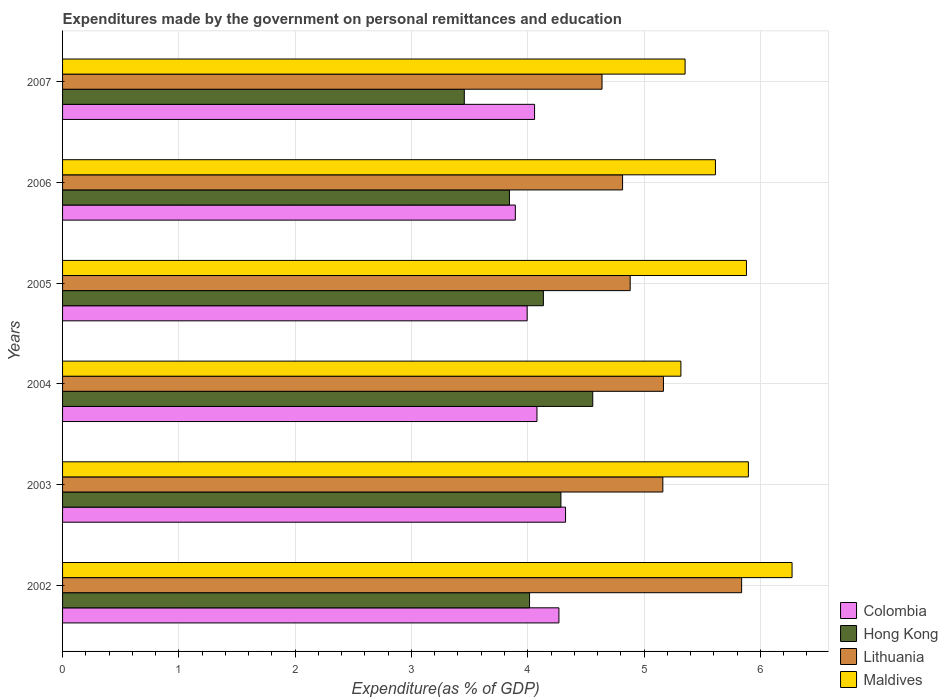How many groups of bars are there?
Provide a short and direct response. 6. Are the number of bars on each tick of the Y-axis equal?
Make the answer very short. Yes. How many bars are there on the 1st tick from the top?
Your response must be concise. 4. What is the expenditures made by the government on personal remittances and education in Lithuania in 2007?
Provide a short and direct response. 4.64. Across all years, what is the maximum expenditures made by the government on personal remittances and education in Hong Kong?
Give a very brief answer. 4.56. Across all years, what is the minimum expenditures made by the government on personal remittances and education in Maldives?
Provide a succinct answer. 5.32. What is the total expenditures made by the government on personal remittances and education in Hong Kong in the graph?
Your response must be concise. 24.29. What is the difference between the expenditures made by the government on personal remittances and education in Colombia in 2004 and that in 2005?
Your answer should be very brief. 0.08. What is the difference between the expenditures made by the government on personal remittances and education in Maldives in 2007 and the expenditures made by the government on personal remittances and education in Colombia in 2003?
Give a very brief answer. 1.03. What is the average expenditures made by the government on personal remittances and education in Maldives per year?
Offer a terse response. 5.72. In the year 2003, what is the difference between the expenditures made by the government on personal remittances and education in Maldives and expenditures made by the government on personal remittances and education in Colombia?
Ensure brevity in your answer.  1.57. In how many years, is the expenditures made by the government on personal remittances and education in Lithuania greater than 2.4 %?
Your answer should be compact. 6. What is the ratio of the expenditures made by the government on personal remittances and education in Hong Kong in 2002 to that in 2006?
Your answer should be very brief. 1.04. Is the expenditures made by the government on personal remittances and education in Hong Kong in 2005 less than that in 2007?
Provide a short and direct response. No. What is the difference between the highest and the second highest expenditures made by the government on personal remittances and education in Maldives?
Your response must be concise. 0.38. What is the difference between the highest and the lowest expenditures made by the government on personal remittances and education in Hong Kong?
Give a very brief answer. 1.1. In how many years, is the expenditures made by the government on personal remittances and education in Hong Kong greater than the average expenditures made by the government on personal remittances and education in Hong Kong taken over all years?
Make the answer very short. 3. Is it the case that in every year, the sum of the expenditures made by the government on personal remittances and education in Hong Kong and expenditures made by the government on personal remittances and education in Maldives is greater than the sum of expenditures made by the government on personal remittances and education in Colombia and expenditures made by the government on personal remittances and education in Lithuania?
Offer a terse response. Yes. What does the 1st bar from the top in 2007 represents?
Provide a short and direct response. Maldives. Is it the case that in every year, the sum of the expenditures made by the government on personal remittances and education in Maldives and expenditures made by the government on personal remittances and education in Hong Kong is greater than the expenditures made by the government on personal remittances and education in Lithuania?
Provide a short and direct response. Yes. Are all the bars in the graph horizontal?
Your answer should be compact. Yes. How many years are there in the graph?
Your answer should be very brief. 6. What is the difference between two consecutive major ticks on the X-axis?
Give a very brief answer. 1. Are the values on the major ticks of X-axis written in scientific E-notation?
Your answer should be compact. No. Where does the legend appear in the graph?
Ensure brevity in your answer.  Bottom right. How are the legend labels stacked?
Your response must be concise. Vertical. What is the title of the graph?
Your answer should be compact. Expenditures made by the government on personal remittances and education. What is the label or title of the X-axis?
Your answer should be very brief. Expenditure(as % of GDP). What is the label or title of the Y-axis?
Provide a short and direct response. Years. What is the Expenditure(as % of GDP) of Colombia in 2002?
Ensure brevity in your answer.  4.27. What is the Expenditure(as % of GDP) of Hong Kong in 2002?
Provide a succinct answer. 4.02. What is the Expenditure(as % of GDP) in Lithuania in 2002?
Your answer should be very brief. 5.84. What is the Expenditure(as % of GDP) of Maldives in 2002?
Ensure brevity in your answer.  6.27. What is the Expenditure(as % of GDP) in Colombia in 2003?
Your response must be concise. 4.33. What is the Expenditure(as % of GDP) in Hong Kong in 2003?
Offer a terse response. 4.29. What is the Expenditure(as % of GDP) in Lithuania in 2003?
Offer a very short reply. 5.16. What is the Expenditure(as % of GDP) of Maldives in 2003?
Ensure brevity in your answer.  5.9. What is the Expenditure(as % of GDP) in Colombia in 2004?
Your answer should be very brief. 4.08. What is the Expenditure(as % of GDP) of Hong Kong in 2004?
Your answer should be compact. 4.56. What is the Expenditure(as % of GDP) of Lithuania in 2004?
Offer a terse response. 5.17. What is the Expenditure(as % of GDP) of Maldives in 2004?
Provide a short and direct response. 5.32. What is the Expenditure(as % of GDP) in Colombia in 2005?
Offer a terse response. 4. What is the Expenditure(as % of GDP) of Hong Kong in 2005?
Provide a succinct answer. 4.13. What is the Expenditure(as % of GDP) in Lithuania in 2005?
Ensure brevity in your answer.  4.88. What is the Expenditure(as % of GDP) in Maldives in 2005?
Provide a succinct answer. 5.88. What is the Expenditure(as % of GDP) in Colombia in 2006?
Keep it short and to the point. 3.89. What is the Expenditure(as % of GDP) in Hong Kong in 2006?
Offer a very short reply. 3.84. What is the Expenditure(as % of GDP) of Lithuania in 2006?
Offer a terse response. 4.82. What is the Expenditure(as % of GDP) in Maldives in 2006?
Make the answer very short. 5.61. What is the Expenditure(as % of GDP) in Colombia in 2007?
Offer a terse response. 4.06. What is the Expenditure(as % of GDP) of Hong Kong in 2007?
Provide a succinct answer. 3.45. What is the Expenditure(as % of GDP) of Lithuania in 2007?
Ensure brevity in your answer.  4.64. What is the Expenditure(as % of GDP) in Maldives in 2007?
Provide a short and direct response. 5.35. Across all years, what is the maximum Expenditure(as % of GDP) of Colombia?
Your answer should be compact. 4.33. Across all years, what is the maximum Expenditure(as % of GDP) in Hong Kong?
Keep it short and to the point. 4.56. Across all years, what is the maximum Expenditure(as % of GDP) in Lithuania?
Keep it short and to the point. 5.84. Across all years, what is the maximum Expenditure(as % of GDP) in Maldives?
Make the answer very short. 6.27. Across all years, what is the minimum Expenditure(as % of GDP) of Colombia?
Your answer should be very brief. 3.89. Across all years, what is the minimum Expenditure(as % of GDP) of Hong Kong?
Provide a short and direct response. 3.45. Across all years, what is the minimum Expenditure(as % of GDP) of Lithuania?
Keep it short and to the point. 4.64. Across all years, what is the minimum Expenditure(as % of GDP) of Maldives?
Offer a very short reply. 5.32. What is the total Expenditure(as % of GDP) in Colombia in the graph?
Offer a terse response. 24.62. What is the total Expenditure(as % of GDP) of Hong Kong in the graph?
Ensure brevity in your answer.  24.29. What is the total Expenditure(as % of GDP) in Lithuania in the graph?
Provide a short and direct response. 30.5. What is the total Expenditure(as % of GDP) of Maldives in the graph?
Offer a very short reply. 34.33. What is the difference between the Expenditure(as % of GDP) of Colombia in 2002 and that in 2003?
Provide a short and direct response. -0.06. What is the difference between the Expenditure(as % of GDP) in Hong Kong in 2002 and that in 2003?
Make the answer very short. -0.27. What is the difference between the Expenditure(as % of GDP) in Lithuania in 2002 and that in 2003?
Make the answer very short. 0.68. What is the difference between the Expenditure(as % of GDP) of Maldives in 2002 and that in 2003?
Your response must be concise. 0.38. What is the difference between the Expenditure(as % of GDP) of Colombia in 2002 and that in 2004?
Give a very brief answer. 0.19. What is the difference between the Expenditure(as % of GDP) of Hong Kong in 2002 and that in 2004?
Keep it short and to the point. -0.54. What is the difference between the Expenditure(as % of GDP) of Lithuania in 2002 and that in 2004?
Provide a short and direct response. 0.67. What is the difference between the Expenditure(as % of GDP) in Maldives in 2002 and that in 2004?
Keep it short and to the point. 0.96. What is the difference between the Expenditure(as % of GDP) in Colombia in 2002 and that in 2005?
Provide a succinct answer. 0.27. What is the difference between the Expenditure(as % of GDP) of Hong Kong in 2002 and that in 2005?
Your answer should be compact. -0.12. What is the difference between the Expenditure(as % of GDP) in Maldives in 2002 and that in 2005?
Offer a very short reply. 0.39. What is the difference between the Expenditure(as % of GDP) of Colombia in 2002 and that in 2006?
Offer a very short reply. 0.37. What is the difference between the Expenditure(as % of GDP) of Hong Kong in 2002 and that in 2006?
Ensure brevity in your answer.  0.17. What is the difference between the Expenditure(as % of GDP) in Lithuania in 2002 and that in 2006?
Your answer should be compact. 1.02. What is the difference between the Expenditure(as % of GDP) of Maldives in 2002 and that in 2006?
Provide a short and direct response. 0.66. What is the difference between the Expenditure(as % of GDP) in Colombia in 2002 and that in 2007?
Make the answer very short. 0.21. What is the difference between the Expenditure(as % of GDP) in Hong Kong in 2002 and that in 2007?
Give a very brief answer. 0.56. What is the difference between the Expenditure(as % of GDP) in Lithuania in 2002 and that in 2007?
Your answer should be compact. 1.2. What is the difference between the Expenditure(as % of GDP) in Maldives in 2002 and that in 2007?
Provide a succinct answer. 0.92. What is the difference between the Expenditure(as % of GDP) of Colombia in 2003 and that in 2004?
Your answer should be compact. 0.25. What is the difference between the Expenditure(as % of GDP) of Hong Kong in 2003 and that in 2004?
Your response must be concise. -0.27. What is the difference between the Expenditure(as % of GDP) of Lithuania in 2003 and that in 2004?
Ensure brevity in your answer.  -0.01. What is the difference between the Expenditure(as % of GDP) in Maldives in 2003 and that in 2004?
Ensure brevity in your answer.  0.58. What is the difference between the Expenditure(as % of GDP) of Colombia in 2003 and that in 2005?
Your response must be concise. 0.33. What is the difference between the Expenditure(as % of GDP) of Hong Kong in 2003 and that in 2005?
Your response must be concise. 0.15. What is the difference between the Expenditure(as % of GDP) of Lithuania in 2003 and that in 2005?
Offer a terse response. 0.28. What is the difference between the Expenditure(as % of GDP) of Maldives in 2003 and that in 2005?
Give a very brief answer. 0.02. What is the difference between the Expenditure(as % of GDP) in Colombia in 2003 and that in 2006?
Give a very brief answer. 0.43. What is the difference between the Expenditure(as % of GDP) in Hong Kong in 2003 and that in 2006?
Your response must be concise. 0.44. What is the difference between the Expenditure(as % of GDP) in Lithuania in 2003 and that in 2006?
Ensure brevity in your answer.  0.35. What is the difference between the Expenditure(as % of GDP) of Maldives in 2003 and that in 2006?
Your answer should be very brief. 0.28. What is the difference between the Expenditure(as % of GDP) of Colombia in 2003 and that in 2007?
Your answer should be very brief. 0.27. What is the difference between the Expenditure(as % of GDP) in Hong Kong in 2003 and that in 2007?
Your answer should be very brief. 0.83. What is the difference between the Expenditure(as % of GDP) of Lithuania in 2003 and that in 2007?
Offer a terse response. 0.52. What is the difference between the Expenditure(as % of GDP) in Maldives in 2003 and that in 2007?
Provide a succinct answer. 0.54. What is the difference between the Expenditure(as % of GDP) in Colombia in 2004 and that in 2005?
Make the answer very short. 0.08. What is the difference between the Expenditure(as % of GDP) in Hong Kong in 2004 and that in 2005?
Offer a very short reply. 0.42. What is the difference between the Expenditure(as % of GDP) of Lithuania in 2004 and that in 2005?
Your answer should be compact. 0.29. What is the difference between the Expenditure(as % of GDP) of Maldives in 2004 and that in 2005?
Make the answer very short. -0.56. What is the difference between the Expenditure(as % of GDP) of Colombia in 2004 and that in 2006?
Your answer should be very brief. 0.19. What is the difference between the Expenditure(as % of GDP) in Hong Kong in 2004 and that in 2006?
Offer a very short reply. 0.72. What is the difference between the Expenditure(as % of GDP) in Lithuania in 2004 and that in 2006?
Provide a short and direct response. 0.35. What is the difference between the Expenditure(as % of GDP) of Maldives in 2004 and that in 2006?
Your response must be concise. -0.3. What is the difference between the Expenditure(as % of GDP) of Colombia in 2004 and that in 2007?
Provide a succinct answer. 0.02. What is the difference between the Expenditure(as % of GDP) of Hong Kong in 2004 and that in 2007?
Provide a succinct answer. 1.1. What is the difference between the Expenditure(as % of GDP) of Lithuania in 2004 and that in 2007?
Provide a succinct answer. 0.53. What is the difference between the Expenditure(as % of GDP) in Maldives in 2004 and that in 2007?
Your answer should be compact. -0.04. What is the difference between the Expenditure(as % of GDP) in Colombia in 2005 and that in 2006?
Offer a very short reply. 0.1. What is the difference between the Expenditure(as % of GDP) in Hong Kong in 2005 and that in 2006?
Your answer should be compact. 0.29. What is the difference between the Expenditure(as % of GDP) in Lithuania in 2005 and that in 2006?
Keep it short and to the point. 0.07. What is the difference between the Expenditure(as % of GDP) in Maldives in 2005 and that in 2006?
Ensure brevity in your answer.  0.27. What is the difference between the Expenditure(as % of GDP) of Colombia in 2005 and that in 2007?
Provide a succinct answer. -0.06. What is the difference between the Expenditure(as % of GDP) of Hong Kong in 2005 and that in 2007?
Give a very brief answer. 0.68. What is the difference between the Expenditure(as % of GDP) of Lithuania in 2005 and that in 2007?
Offer a terse response. 0.24. What is the difference between the Expenditure(as % of GDP) in Maldives in 2005 and that in 2007?
Provide a succinct answer. 0.53. What is the difference between the Expenditure(as % of GDP) of Colombia in 2006 and that in 2007?
Your response must be concise. -0.17. What is the difference between the Expenditure(as % of GDP) in Hong Kong in 2006 and that in 2007?
Provide a succinct answer. 0.39. What is the difference between the Expenditure(as % of GDP) of Lithuania in 2006 and that in 2007?
Your response must be concise. 0.18. What is the difference between the Expenditure(as % of GDP) of Maldives in 2006 and that in 2007?
Provide a succinct answer. 0.26. What is the difference between the Expenditure(as % of GDP) of Colombia in 2002 and the Expenditure(as % of GDP) of Hong Kong in 2003?
Ensure brevity in your answer.  -0.02. What is the difference between the Expenditure(as % of GDP) of Colombia in 2002 and the Expenditure(as % of GDP) of Lithuania in 2003?
Your answer should be compact. -0.89. What is the difference between the Expenditure(as % of GDP) in Colombia in 2002 and the Expenditure(as % of GDP) in Maldives in 2003?
Offer a terse response. -1.63. What is the difference between the Expenditure(as % of GDP) in Hong Kong in 2002 and the Expenditure(as % of GDP) in Lithuania in 2003?
Provide a short and direct response. -1.15. What is the difference between the Expenditure(as % of GDP) in Hong Kong in 2002 and the Expenditure(as % of GDP) in Maldives in 2003?
Provide a short and direct response. -1.88. What is the difference between the Expenditure(as % of GDP) of Lithuania in 2002 and the Expenditure(as % of GDP) of Maldives in 2003?
Your answer should be very brief. -0.06. What is the difference between the Expenditure(as % of GDP) of Colombia in 2002 and the Expenditure(as % of GDP) of Hong Kong in 2004?
Keep it short and to the point. -0.29. What is the difference between the Expenditure(as % of GDP) in Colombia in 2002 and the Expenditure(as % of GDP) in Lithuania in 2004?
Ensure brevity in your answer.  -0.9. What is the difference between the Expenditure(as % of GDP) of Colombia in 2002 and the Expenditure(as % of GDP) of Maldives in 2004?
Ensure brevity in your answer.  -1.05. What is the difference between the Expenditure(as % of GDP) in Hong Kong in 2002 and the Expenditure(as % of GDP) in Lithuania in 2004?
Your response must be concise. -1.15. What is the difference between the Expenditure(as % of GDP) in Hong Kong in 2002 and the Expenditure(as % of GDP) in Maldives in 2004?
Keep it short and to the point. -1.3. What is the difference between the Expenditure(as % of GDP) in Lithuania in 2002 and the Expenditure(as % of GDP) in Maldives in 2004?
Offer a very short reply. 0.52. What is the difference between the Expenditure(as % of GDP) of Colombia in 2002 and the Expenditure(as % of GDP) of Hong Kong in 2005?
Your response must be concise. 0.13. What is the difference between the Expenditure(as % of GDP) of Colombia in 2002 and the Expenditure(as % of GDP) of Lithuania in 2005?
Offer a terse response. -0.61. What is the difference between the Expenditure(as % of GDP) in Colombia in 2002 and the Expenditure(as % of GDP) in Maldives in 2005?
Ensure brevity in your answer.  -1.61. What is the difference between the Expenditure(as % of GDP) of Hong Kong in 2002 and the Expenditure(as % of GDP) of Lithuania in 2005?
Offer a very short reply. -0.87. What is the difference between the Expenditure(as % of GDP) in Hong Kong in 2002 and the Expenditure(as % of GDP) in Maldives in 2005?
Ensure brevity in your answer.  -1.87. What is the difference between the Expenditure(as % of GDP) of Lithuania in 2002 and the Expenditure(as % of GDP) of Maldives in 2005?
Keep it short and to the point. -0.04. What is the difference between the Expenditure(as % of GDP) in Colombia in 2002 and the Expenditure(as % of GDP) in Hong Kong in 2006?
Your response must be concise. 0.43. What is the difference between the Expenditure(as % of GDP) of Colombia in 2002 and the Expenditure(as % of GDP) of Lithuania in 2006?
Your answer should be compact. -0.55. What is the difference between the Expenditure(as % of GDP) in Colombia in 2002 and the Expenditure(as % of GDP) in Maldives in 2006?
Ensure brevity in your answer.  -1.35. What is the difference between the Expenditure(as % of GDP) of Hong Kong in 2002 and the Expenditure(as % of GDP) of Lithuania in 2006?
Keep it short and to the point. -0.8. What is the difference between the Expenditure(as % of GDP) of Hong Kong in 2002 and the Expenditure(as % of GDP) of Maldives in 2006?
Provide a succinct answer. -1.6. What is the difference between the Expenditure(as % of GDP) in Lithuania in 2002 and the Expenditure(as % of GDP) in Maldives in 2006?
Offer a terse response. 0.23. What is the difference between the Expenditure(as % of GDP) of Colombia in 2002 and the Expenditure(as % of GDP) of Hong Kong in 2007?
Provide a succinct answer. 0.81. What is the difference between the Expenditure(as % of GDP) in Colombia in 2002 and the Expenditure(as % of GDP) in Lithuania in 2007?
Your answer should be very brief. -0.37. What is the difference between the Expenditure(as % of GDP) of Colombia in 2002 and the Expenditure(as % of GDP) of Maldives in 2007?
Provide a short and direct response. -1.08. What is the difference between the Expenditure(as % of GDP) of Hong Kong in 2002 and the Expenditure(as % of GDP) of Lithuania in 2007?
Your answer should be very brief. -0.62. What is the difference between the Expenditure(as % of GDP) in Hong Kong in 2002 and the Expenditure(as % of GDP) in Maldives in 2007?
Offer a very short reply. -1.34. What is the difference between the Expenditure(as % of GDP) in Lithuania in 2002 and the Expenditure(as % of GDP) in Maldives in 2007?
Your response must be concise. 0.49. What is the difference between the Expenditure(as % of GDP) of Colombia in 2003 and the Expenditure(as % of GDP) of Hong Kong in 2004?
Ensure brevity in your answer.  -0.23. What is the difference between the Expenditure(as % of GDP) in Colombia in 2003 and the Expenditure(as % of GDP) in Lithuania in 2004?
Offer a terse response. -0.84. What is the difference between the Expenditure(as % of GDP) of Colombia in 2003 and the Expenditure(as % of GDP) of Maldives in 2004?
Make the answer very short. -0.99. What is the difference between the Expenditure(as % of GDP) of Hong Kong in 2003 and the Expenditure(as % of GDP) of Lithuania in 2004?
Ensure brevity in your answer.  -0.88. What is the difference between the Expenditure(as % of GDP) in Hong Kong in 2003 and the Expenditure(as % of GDP) in Maldives in 2004?
Make the answer very short. -1.03. What is the difference between the Expenditure(as % of GDP) in Lithuania in 2003 and the Expenditure(as % of GDP) in Maldives in 2004?
Offer a terse response. -0.16. What is the difference between the Expenditure(as % of GDP) of Colombia in 2003 and the Expenditure(as % of GDP) of Hong Kong in 2005?
Provide a short and direct response. 0.19. What is the difference between the Expenditure(as % of GDP) in Colombia in 2003 and the Expenditure(as % of GDP) in Lithuania in 2005?
Your response must be concise. -0.56. What is the difference between the Expenditure(as % of GDP) of Colombia in 2003 and the Expenditure(as % of GDP) of Maldives in 2005?
Provide a short and direct response. -1.56. What is the difference between the Expenditure(as % of GDP) of Hong Kong in 2003 and the Expenditure(as % of GDP) of Lithuania in 2005?
Your response must be concise. -0.6. What is the difference between the Expenditure(as % of GDP) of Hong Kong in 2003 and the Expenditure(as % of GDP) of Maldives in 2005?
Ensure brevity in your answer.  -1.6. What is the difference between the Expenditure(as % of GDP) in Lithuania in 2003 and the Expenditure(as % of GDP) in Maldives in 2005?
Your response must be concise. -0.72. What is the difference between the Expenditure(as % of GDP) in Colombia in 2003 and the Expenditure(as % of GDP) in Hong Kong in 2006?
Offer a very short reply. 0.48. What is the difference between the Expenditure(as % of GDP) of Colombia in 2003 and the Expenditure(as % of GDP) of Lithuania in 2006?
Make the answer very short. -0.49. What is the difference between the Expenditure(as % of GDP) of Colombia in 2003 and the Expenditure(as % of GDP) of Maldives in 2006?
Offer a terse response. -1.29. What is the difference between the Expenditure(as % of GDP) in Hong Kong in 2003 and the Expenditure(as % of GDP) in Lithuania in 2006?
Provide a succinct answer. -0.53. What is the difference between the Expenditure(as % of GDP) in Hong Kong in 2003 and the Expenditure(as % of GDP) in Maldives in 2006?
Make the answer very short. -1.33. What is the difference between the Expenditure(as % of GDP) in Lithuania in 2003 and the Expenditure(as % of GDP) in Maldives in 2006?
Keep it short and to the point. -0.45. What is the difference between the Expenditure(as % of GDP) of Colombia in 2003 and the Expenditure(as % of GDP) of Hong Kong in 2007?
Offer a terse response. 0.87. What is the difference between the Expenditure(as % of GDP) of Colombia in 2003 and the Expenditure(as % of GDP) of Lithuania in 2007?
Ensure brevity in your answer.  -0.31. What is the difference between the Expenditure(as % of GDP) in Colombia in 2003 and the Expenditure(as % of GDP) in Maldives in 2007?
Your response must be concise. -1.03. What is the difference between the Expenditure(as % of GDP) of Hong Kong in 2003 and the Expenditure(as % of GDP) of Lithuania in 2007?
Ensure brevity in your answer.  -0.35. What is the difference between the Expenditure(as % of GDP) of Hong Kong in 2003 and the Expenditure(as % of GDP) of Maldives in 2007?
Your response must be concise. -1.07. What is the difference between the Expenditure(as % of GDP) in Lithuania in 2003 and the Expenditure(as % of GDP) in Maldives in 2007?
Provide a succinct answer. -0.19. What is the difference between the Expenditure(as % of GDP) in Colombia in 2004 and the Expenditure(as % of GDP) in Hong Kong in 2005?
Provide a short and direct response. -0.06. What is the difference between the Expenditure(as % of GDP) in Colombia in 2004 and the Expenditure(as % of GDP) in Lithuania in 2005?
Keep it short and to the point. -0.8. What is the difference between the Expenditure(as % of GDP) in Colombia in 2004 and the Expenditure(as % of GDP) in Maldives in 2005?
Ensure brevity in your answer.  -1.8. What is the difference between the Expenditure(as % of GDP) of Hong Kong in 2004 and the Expenditure(as % of GDP) of Lithuania in 2005?
Ensure brevity in your answer.  -0.32. What is the difference between the Expenditure(as % of GDP) of Hong Kong in 2004 and the Expenditure(as % of GDP) of Maldives in 2005?
Your response must be concise. -1.32. What is the difference between the Expenditure(as % of GDP) of Lithuania in 2004 and the Expenditure(as % of GDP) of Maldives in 2005?
Your response must be concise. -0.71. What is the difference between the Expenditure(as % of GDP) in Colombia in 2004 and the Expenditure(as % of GDP) in Hong Kong in 2006?
Offer a very short reply. 0.24. What is the difference between the Expenditure(as % of GDP) in Colombia in 2004 and the Expenditure(as % of GDP) in Lithuania in 2006?
Your answer should be very brief. -0.74. What is the difference between the Expenditure(as % of GDP) in Colombia in 2004 and the Expenditure(as % of GDP) in Maldives in 2006?
Your response must be concise. -1.53. What is the difference between the Expenditure(as % of GDP) of Hong Kong in 2004 and the Expenditure(as % of GDP) of Lithuania in 2006?
Offer a very short reply. -0.26. What is the difference between the Expenditure(as % of GDP) of Hong Kong in 2004 and the Expenditure(as % of GDP) of Maldives in 2006?
Your answer should be compact. -1.05. What is the difference between the Expenditure(as % of GDP) in Lithuania in 2004 and the Expenditure(as % of GDP) in Maldives in 2006?
Your response must be concise. -0.45. What is the difference between the Expenditure(as % of GDP) in Colombia in 2004 and the Expenditure(as % of GDP) in Hong Kong in 2007?
Your response must be concise. 0.62. What is the difference between the Expenditure(as % of GDP) of Colombia in 2004 and the Expenditure(as % of GDP) of Lithuania in 2007?
Give a very brief answer. -0.56. What is the difference between the Expenditure(as % of GDP) in Colombia in 2004 and the Expenditure(as % of GDP) in Maldives in 2007?
Make the answer very short. -1.27. What is the difference between the Expenditure(as % of GDP) of Hong Kong in 2004 and the Expenditure(as % of GDP) of Lithuania in 2007?
Provide a succinct answer. -0.08. What is the difference between the Expenditure(as % of GDP) in Hong Kong in 2004 and the Expenditure(as % of GDP) in Maldives in 2007?
Provide a short and direct response. -0.79. What is the difference between the Expenditure(as % of GDP) of Lithuania in 2004 and the Expenditure(as % of GDP) of Maldives in 2007?
Provide a short and direct response. -0.19. What is the difference between the Expenditure(as % of GDP) of Colombia in 2005 and the Expenditure(as % of GDP) of Hong Kong in 2006?
Offer a very short reply. 0.15. What is the difference between the Expenditure(as % of GDP) in Colombia in 2005 and the Expenditure(as % of GDP) in Lithuania in 2006?
Your response must be concise. -0.82. What is the difference between the Expenditure(as % of GDP) of Colombia in 2005 and the Expenditure(as % of GDP) of Maldives in 2006?
Provide a succinct answer. -1.62. What is the difference between the Expenditure(as % of GDP) in Hong Kong in 2005 and the Expenditure(as % of GDP) in Lithuania in 2006?
Ensure brevity in your answer.  -0.68. What is the difference between the Expenditure(as % of GDP) of Hong Kong in 2005 and the Expenditure(as % of GDP) of Maldives in 2006?
Make the answer very short. -1.48. What is the difference between the Expenditure(as % of GDP) of Lithuania in 2005 and the Expenditure(as % of GDP) of Maldives in 2006?
Ensure brevity in your answer.  -0.73. What is the difference between the Expenditure(as % of GDP) in Colombia in 2005 and the Expenditure(as % of GDP) in Hong Kong in 2007?
Offer a terse response. 0.54. What is the difference between the Expenditure(as % of GDP) of Colombia in 2005 and the Expenditure(as % of GDP) of Lithuania in 2007?
Keep it short and to the point. -0.64. What is the difference between the Expenditure(as % of GDP) of Colombia in 2005 and the Expenditure(as % of GDP) of Maldives in 2007?
Offer a very short reply. -1.36. What is the difference between the Expenditure(as % of GDP) in Hong Kong in 2005 and the Expenditure(as % of GDP) in Lithuania in 2007?
Offer a terse response. -0.5. What is the difference between the Expenditure(as % of GDP) of Hong Kong in 2005 and the Expenditure(as % of GDP) of Maldives in 2007?
Make the answer very short. -1.22. What is the difference between the Expenditure(as % of GDP) in Lithuania in 2005 and the Expenditure(as % of GDP) in Maldives in 2007?
Provide a succinct answer. -0.47. What is the difference between the Expenditure(as % of GDP) of Colombia in 2006 and the Expenditure(as % of GDP) of Hong Kong in 2007?
Make the answer very short. 0.44. What is the difference between the Expenditure(as % of GDP) in Colombia in 2006 and the Expenditure(as % of GDP) in Lithuania in 2007?
Offer a very short reply. -0.75. What is the difference between the Expenditure(as % of GDP) of Colombia in 2006 and the Expenditure(as % of GDP) of Maldives in 2007?
Your answer should be very brief. -1.46. What is the difference between the Expenditure(as % of GDP) in Hong Kong in 2006 and the Expenditure(as % of GDP) in Lithuania in 2007?
Offer a very short reply. -0.8. What is the difference between the Expenditure(as % of GDP) of Hong Kong in 2006 and the Expenditure(as % of GDP) of Maldives in 2007?
Provide a succinct answer. -1.51. What is the difference between the Expenditure(as % of GDP) in Lithuania in 2006 and the Expenditure(as % of GDP) in Maldives in 2007?
Offer a very short reply. -0.54. What is the average Expenditure(as % of GDP) in Colombia per year?
Offer a terse response. 4.1. What is the average Expenditure(as % of GDP) of Hong Kong per year?
Offer a terse response. 4.05. What is the average Expenditure(as % of GDP) in Lithuania per year?
Your answer should be very brief. 5.08. What is the average Expenditure(as % of GDP) of Maldives per year?
Your answer should be very brief. 5.72. In the year 2002, what is the difference between the Expenditure(as % of GDP) in Colombia and Expenditure(as % of GDP) in Hong Kong?
Your answer should be very brief. 0.25. In the year 2002, what is the difference between the Expenditure(as % of GDP) in Colombia and Expenditure(as % of GDP) in Lithuania?
Offer a very short reply. -1.57. In the year 2002, what is the difference between the Expenditure(as % of GDP) of Colombia and Expenditure(as % of GDP) of Maldives?
Provide a succinct answer. -2. In the year 2002, what is the difference between the Expenditure(as % of GDP) in Hong Kong and Expenditure(as % of GDP) in Lithuania?
Your answer should be compact. -1.82. In the year 2002, what is the difference between the Expenditure(as % of GDP) of Hong Kong and Expenditure(as % of GDP) of Maldives?
Your answer should be very brief. -2.26. In the year 2002, what is the difference between the Expenditure(as % of GDP) in Lithuania and Expenditure(as % of GDP) in Maldives?
Offer a very short reply. -0.43. In the year 2003, what is the difference between the Expenditure(as % of GDP) in Colombia and Expenditure(as % of GDP) in Hong Kong?
Your answer should be compact. 0.04. In the year 2003, what is the difference between the Expenditure(as % of GDP) in Colombia and Expenditure(as % of GDP) in Lithuania?
Your response must be concise. -0.84. In the year 2003, what is the difference between the Expenditure(as % of GDP) in Colombia and Expenditure(as % of GDP) in Maldives?
Provide a succinct answer. -1.57. In the year 2003, what is the difference between the Expenditure(as % of GDP) in Hong Kong and Expenditure(as % of GDP) in Lithuania?
Your answer should be compact. -0.88. In the year 2003, what is the difference between the Expenditure(as % of GDP) in Hong Kong and Expenditure(as % of GDP) in Maldives?
Provide a short and direct response. -1.61. In the year 2003, what is the difference between the Expenditure(as % of GDP) of Lithuania and Expenditure(as % of GDP) of Maldives?
Ensure brevity in your answer.  -0.74. In the year 2004, what is the difference between the Expenditure(as % of GDP) of Colombia and Expenditure(as % of GDP) of Hong Kong?
Your response must be concise. -0.48. In the year 2004, what is the difference between the Expenditure(as % of GDP) of Colombia and Expenditure(as % of GDP) of Lithuania?
Ensure brevity in your answer.  -1.09. In the year 2004, what is the difference between the Expenditure(as % of GDP) in Colombia and Expenditure(as % of GDP) in Maldives?
Your response must be concise. -1.24. In the year 2004, what is the difference between the Expenditure(as % of GDP) in Hong Kong and Expenditure(as % of GDP) in Lithuania?
Offer a very short reply. -0.61. In the year 2004, what is the difference between the Expenditure(as % of GDP) of Hong Kong and Expenditure(as % of GDP) of Maldives?
Your answer should be compact. -0.76. In the year 2004, what is the difference between the Expenditure(as % of GDP) in Lithuania and Expenditure(as % of GDP) in Maldives?
Ensure brevity in your answer.  -0.15. In the year 2005, what is the difference between the Expenditure(as % of GDP) of Colombia and Expenditure(as % of GDP) of Hong Kong?
Provide a short and direct response. -0.14. In the year 2005, what is the difference between the Expenditure(as % of GDP) in Colombia and Expenditure(as % of GDP) in Lithuania?
Give a very brief answer. -0.89. In the year 2005, what is the difference between the Expenditure(as % of GDP) in Colombia and Expenditure(as % of GDP) in Maldives?
Your answer should be very brief. -1.89. In the year 2005, what is the difference between the Expenditure(as % of GDP) of Hong Kong and Expenditure(as % of GDP) of Lithuania?
Your answer should be compact. -0.75. In the year 2005, what is the difference between the Expenditure(as % of GDP) in Hong Kong and Expenditure(as % of GDP) in Maldives?
Provide a short and direct response. -1.75. In the year 2005, what is the difference between the Expenditure(as % of GDP) in Lithuania and Expenditure(as % of GDP) in Maldives?
Your answer should be compact. -1. In the year 2006, what is the difference between the Expenditure(as % of GDP) in Colombia and Expenditure(as % of GDP) in Hong Kong?
Your response must be concise. 0.05. In the year 2006, what is the difference between the Expenditure(as % of GDP) in Colombia and Expenditure(as % of GDP) in Lithuania?
Make the answer very short. -0.92. In the year 2006, what is the difference between the Expenditure(as % of GDP) of Colombia and Expenditure(as % of GDP) of Maldives?
Offer a terse response. -1.72. In the year 2006, what is the difference between the Expenditure(as % of GDP) in Hong Kong and Expenditure(as % of GDP) in Lithuania?
Your answer should be compact. -0.97. In the year 2006, what is the difference between the Expenditure(as % of GDP) in Hong Kong and Expenditure(as % of GDP) in Maldives?
Provide a short and direct response. -1.77. In the year 2006, what is the difference between the Expenditure(as % of GDP) of Lithuania and Expenditure(as % of GDP) of Maldives?
Keep it short and to the point. -0.8. In the year 2007, what is the difference between the Expenditure(as % of GDP) in Colombia and Expenditure(as % of GDP) in Hong Kong?
Ensure brevity in your answer.  0.6. In the year 2007, what is the difference between the Expenditure(as % of GDP) of Colombia and Expenditure(as % of GDP) of Lithuania?
Ensure brevity in your answer.  -0.58. In the year 2007, what is the difference between the Expenditure(as % of GDP) of Colombia and Expenditure(as % of GDP) of Maldives?
Your answer should be very brief. -1.29. In the year 2007, what is the difference between the Expenditure(as % of GDP) of Hong Kong and Expenditure(as % of GDP) of Lithuania?
Ensure brevity in your answer.  -1.18. In the year 2007, what is the difference between the Expenditure(as % of GDP) in Hong Kong and Expenditure(as % of GDP) in Maldives?
Offer a terse response. -1.9. In the year 2007, what is the difference between the Expenditure(as % of GDP) of Lithuania and Expenditure(as % of GDP) of Maldives?
Provide a succinct answer. -0.71. What is the ratio of the Expenditure(as % of GDP) of Colombia in 2002 to that in 2003?
Give a very brief answer. 0.99. What is the ratio of the Expenditure(as % of GDP) of Hong Kong in 2002 to that in 2003?
Offer a very short reply. 0.94. What is the ratio of the Expenditure(as % of GDP) of Lithuania in 2002 to that in 2003?
Provide a succinct answer. 1.13. What is the ratio of the Expenditure(as % of GDP) of Maldives in 2002 to that in 2003?
Your response must be concise. 1.06. What is the ratio of the Expenditure(as % of GDP) of Colombia in 2002 to that in 2004?
Offer a terse response. 1.05. What is the ratio of the Expenditure(as % of GDP) in Hong Kong in 2002 to that in 2004?
Your response must be concise. 0.88. What is the ratio of the Expenditure(as % of GDP) of Lithuania in 2002 to that in 2004?
Provide a succinct answer. 1.13. What is the ratio of the Expenditure(as % of GDP) of Maldives in 2002 to that in 2004?
Your answer should be very brief. 1.18. What is the ratio of the Expenditure(as % of GDP) in Colombia in 2002 to that in 2005?
Keep it short and to the point. 1.07. What is the ratio of the Expenditure(as % of GDP) in Hong Kong in 2002 to that in 2005?
Provide a succinct answer. 0.97. What is the ratio of the Expenditure(as % of GDP) of Lithuania in 2002 to that in 2005?
Your response must be concise. 1.2. What is the ratio of the Expenditure(as % of GDP) in Maldives in 2002 to that in 2005?
Offer a terse response. 1.07. What is the ratio of the Expenditure(as % of GDP) in Colombia in 2002 to that in 2006?
Your answer should be compact. 1.1. What is the ratio of the Expenditure(as % of GDP) of Hong Kong in 2002 to that in 2006?
Offer a terse response. 1.04. What is the ratio of the Expenditure(as % of GDP) in Lithuania in 2002 to that in 2006?
Provide a succinct answer. 1.21. What is the ratio of the Expenditure(as % of GDP) of Maldives in 2002 to that in 2006?
Keep it short and to the point. 1.12. What is the ratio of the Expenditure(as % of GDP) in Colombia in 2002 to that in 2007?
Keep it short and to the point. 1.05. What is the ratio of the Expenditure(as % of GDP) of Hong Kong in 2002 to that in 2007?
Ensure brevity in your answer.  1.16. What is the ratio of the Expenditure(as % of GDP) in Lithuania in 2002 to that in 2007?
Ensure brevity in your answer.  1.26. What is the ratio of the Expenditure(as % of GDP) of Maldives in 2002 to that in 2007?
Your response must be concise. 1.17. What is the ratio of the Expenditure(as % of GDP) in Colombia in 2003 to that in 2004?
Your answer should be very brief. 1.06. What is the ratio of the Expenditure(as % of GDP) in Lithuania in 2003 to that in 2004?
Ensure brevity in your answer.  1. What is the ratio of the Expenditure(as % of GDP) of Maldives in 2003 to that in 2004?
Your answer should be compact. 1.11. What is the ratio of the Expenditure(as % of GDP) of Colombia in 2003 to that in 2005?
Ensure brevity in your answer.  1.08. What is the ratio of the Expenditure(as % of GDP) of Hong Kong in 2003 to that in 2005?
Offer a terse response. 1.04. What is the ratio of the Expenditure(as % of GDP) of Lithuania in 2003 to that in 2005?
Your response must be concise. 1.06. What is the ratio of the Expenditure(as % of GDP) in Colombia in 2003 to that in 2006?
Give a very brief answer. 1.11. What is the ratio of the Expenditure(as % of GDP) of Hong Kong in 2003 to that in 2006?
Offer a very short reply. 1.12. What is the ratio of the Expenditure(as % of GDP) of Lithuania in 2003 to that in 2006?
Your answer should be very brief. 1.07. What is the ratio of the Expenditure(as % of GDP) in Maldives in 2003 to that in 2006?
Your answer should be compact. 1.05. What is the ratio of the Expenditure(as % of GDP) of Colombia in 2003 to that in 2007?
Provide a succinct answer. 1.07. What is the ratio of the Expenditure(as % of GDP) in Hong Kong in 2003 to that in 2007?
Offer a terse response. 1.24. What is the ratio of the Expenditure(as % of GDP) in Lithuania in 2003 to that in 2007?
Provide a succinct answer. 1.11. What is the ratio of the Expenditure(as % of GDP) in Maldives in 2003 to that in 2007?
Keep it short and to the point. 1.1. What is the ratio of the Expenditure(as % of GDP) of Colombia in 2004 to that in 2005?
Make the answer very short. 1.02. What is the ratio of the Expenditure(as % of GDP) of Hong Kong in 2004 to that in 2005?
Your answer should be compact. 1.1. What is the ratio of the Expenditure(as % of GDP) in Lithuania in 2004 to that in 2005?
Ensure brevity in your answer.  1.06. What is the ratio of the Expenditure(as % of GDP) of Maldives in 2004 to that in 2005?
Give a very brief answer. 0.9. What is the ratio of the Expenditure(as % of GDP) of Colombia in 2004 to that in 2006?
Make the answer very short. 1.05. What is the ratio of the Expenditure(as % of GDP) in Hong Kong in 2004 to that in 2006?
Offer a terse response. 1.19. What is the ratio of the Expenditure(as % of GDP) in Lithuania in 2004 to that in 2006?
Offer a terse response. 1.07. What is the ratio of the Expenditure(as % of GDP) in Maldives in 2004 to that in 2006?
Make the answer very short. 0.95. What is the ratio of the Expenditure(as % of GDP) in Hong Kong in 2004 to that in 2007?
Your answer should be compact. 1.32. What is the ratio of the Expenditure(as % of GDP) in Lithuania in 2004 to that in 2007?
Provide a succinct answer. 1.11. What is the ratio of the Expenditure(as % of GDP) of Maldives in 2004 to that in 2007?
Keep it short and to the point. 0.99. What is the ratio of the Expenditure(as % of GDP) of Colombia in 2005 to that in 2006?
Provide a short and direct response. 1.03. What is the ratio of the Expenditure(as % of GDP) in Hong Kong in 2005 to that in 2006?
Your answer should be very brief. 1.08. What is the ratio of the Expenditure(as % of GDP) in Lithuania in 2005 to that in 2006?
Keep it short and to the point. 1.01. What is the ratio of the Expenditure(as % of GDP) of Maldives in 2005 to that in 2006?
Your answer should be very brief. 1.05. What is the ratio of the Expenditure(as % of GDP) in Colombia in 2005 to that in 2007?
Your answer should be very brief. 0.98. What is the ratio of the Expenditure(as % of GDP) of Hong Kong in 2005 to that in 2007?
Give a very brief answer. 1.2. What is the ratio of the Expenditure(as % of GDP) in Lithuania in 2005 to that in 2007?
Your answer should be very brief. 1.05. What is the ratio of the Expenditure(as % of GDP) of Maldives in 2005 to that in 2007?
Give a very brief answer. 1.1. What is the ratio of the Expenditure(as % of GDP) in Colombia in 2006 to that in 2007?
Keep it short and to the point. 0.96. What is the ratio of the Expenditure(as % of GDP) of Hong Kong in 2006 to that in 2007?
Offer a very short reply. 1.11. What is the ratio of the Expenditure(as % of GDP) in Lithuania in 2006 to that in 2007?
Ensure brevity in your answer.  1.04. What is the ratio of the Expenditure(as % of GDP) of Maldives in 2006 to that in 2007?
Your answer should be compact. 1.05. What is the difference between the highest and the second highest Expenditure(as % of GDP) in Colombia?
Offer a very short reply. 0.06. What is the difference between the highest and the second highest Expenditure(as % of GDP) of Hong Kong?
Offer a very short reply. 0.27. What is the difference between the highest and the second highest Expenditure(as % of GDP) of Lithuania?
Keep it short and to the point. 0.67. What is the difference between the highest and the second highest Expenditure(as % of GDP) in Maldives?
Provide a short and direct response. 0.38. What is the difference between the highest and the lowest Expenditure(as % of GDP) in Colombia?
Offer a terse response. 0.43. What is the difference between the highest and the lowest Expenditure(as % of GDP) in Hong Kong?
Offer a terse response. 1.1. What is the difference between the highest and the lowest Expenditure(as % of GDP) in Lithuania?
Your answer should be very brief. 1.2. What is the difference between the highest and the lowest Expenditure(as % of GDP) in Maldives?
Offer a terse response. 0.96. 